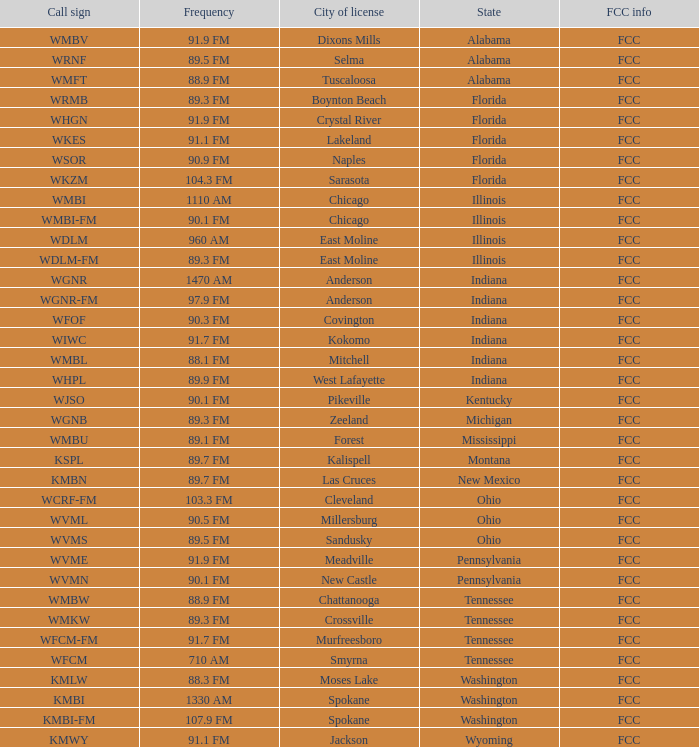What is the frequency of the radio station in Indiana that has a call sign of WGNR? 1470 AM. 